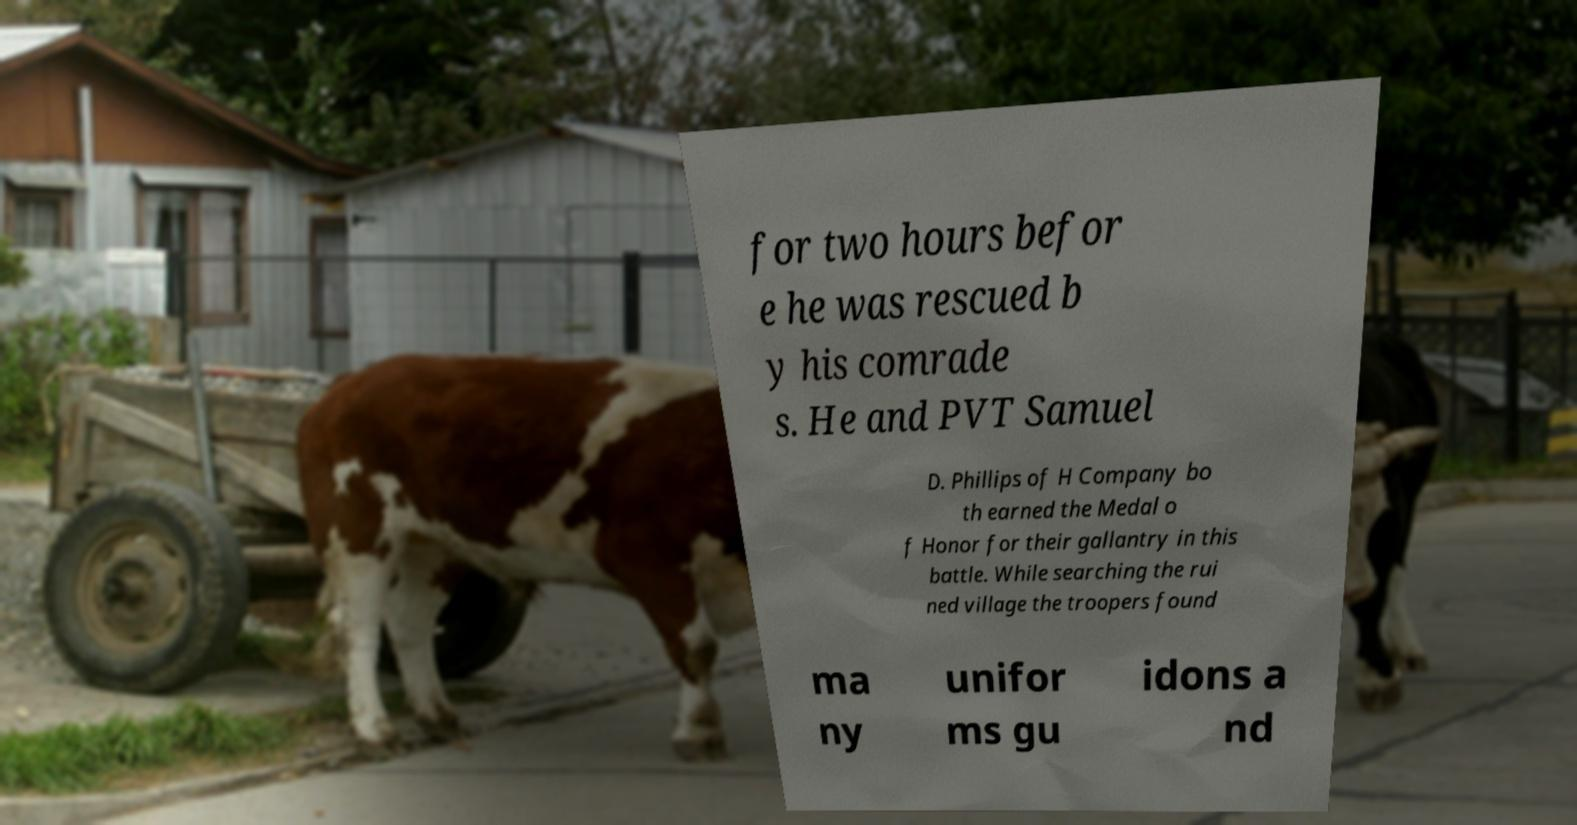Could you assist in decoding the text presented in this image and type it out clearly? for two hours befor e he was rescued b y his comrade s. He and PVT Samuel D. Phillips of H Company bo th earned the Medal o f Honor for their gallantry in this battle. While searching the rui ned village the troopers found ma ny unifor ms gu idons a nd 